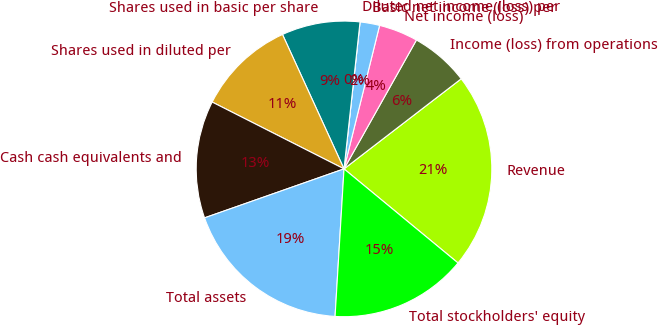Convert chart to OTSL. <chart><loc_0><loc_0><loc_500><loc_500><pie_chart><fcel>Revenue<fcel>Income (loss) from operations<fcel>Net income (loss)<fcel>Basic net income (loss) per<fcel>Diluted net income (loss) per<fcel>Shares used in basic per share<fcel>Shares used in diluted per<fcel>Cash cash equivalents and<fcel>Total assets<fcel>Total stockholders' equity<nl><fcel>21.41%<fcel>6.42%<fcel>4.28%<fcel>2.14%<fcel>0.0%<fcel>8.56%<fcel>10.7%<fcel>12.84%<fcel>18.66%<fcel>14.98%<nl></chart> 